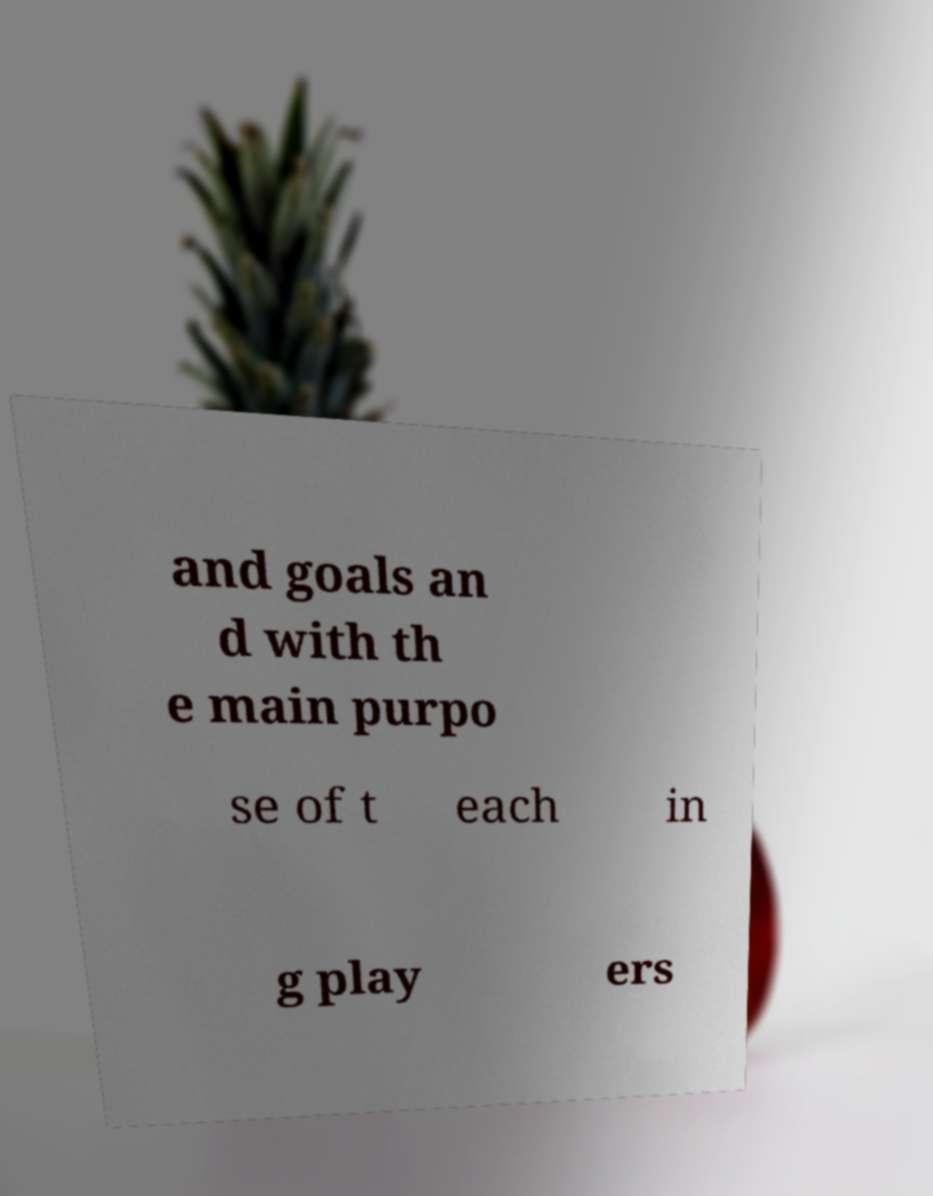I need the written content from this picture converted into text. Can you do that? and goals an d with th e main purpo se of t each in g play ers 